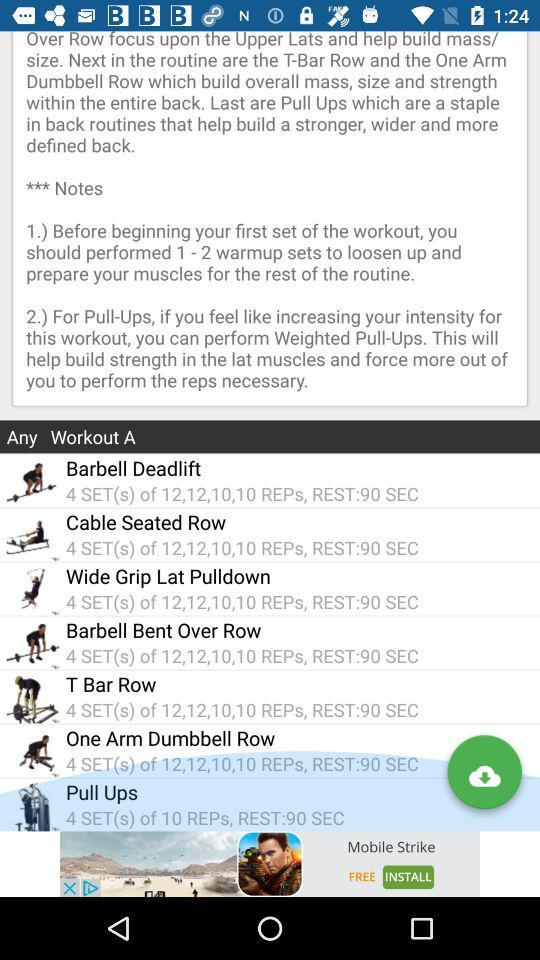What are the different workouts available? The different workouts available are "Barbell Deadlift", "Cable Seated Row", "Wide Grip Lat Pulldown", "Barbell Bent Over Row", "T Bar Row", "One Arm Dumbbell Row" and "Pull Ups". 